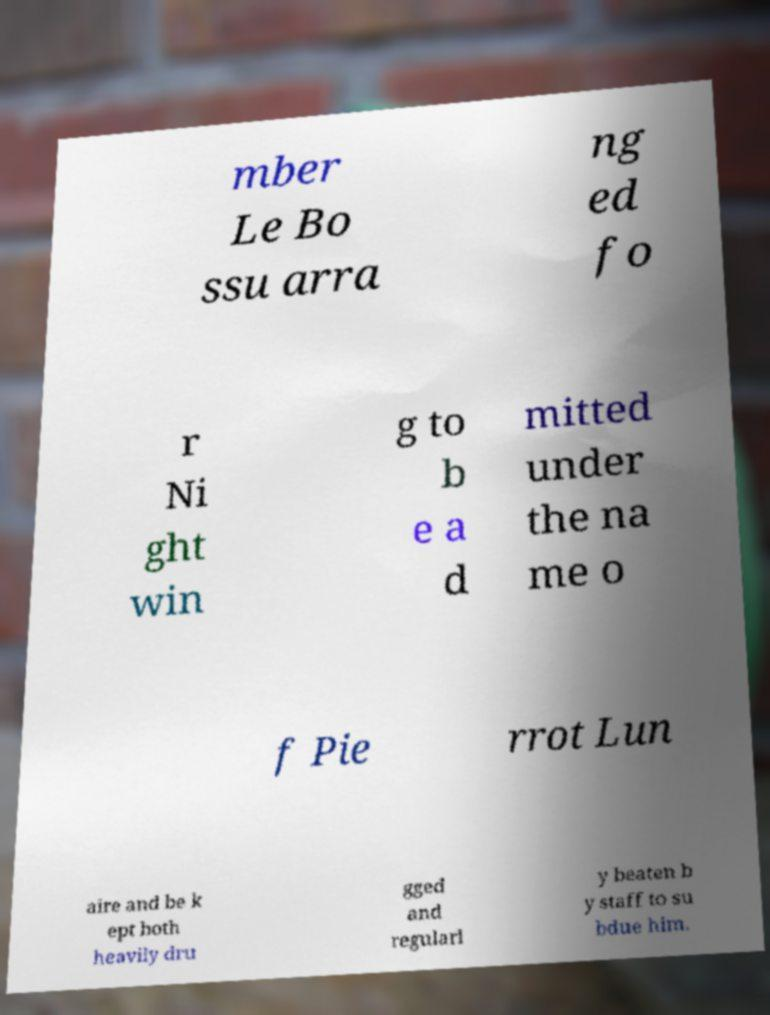What messages or text are displayed in this image? I need them in a readable, typed format. mber Le Bo ssu arra ng ed fo r Ni ght win g to b e a d mitted under the na me o f Pie rrot Lun aire and be k ept both heavily dru gged and regularl y beaten b y staff to su bdue him. 